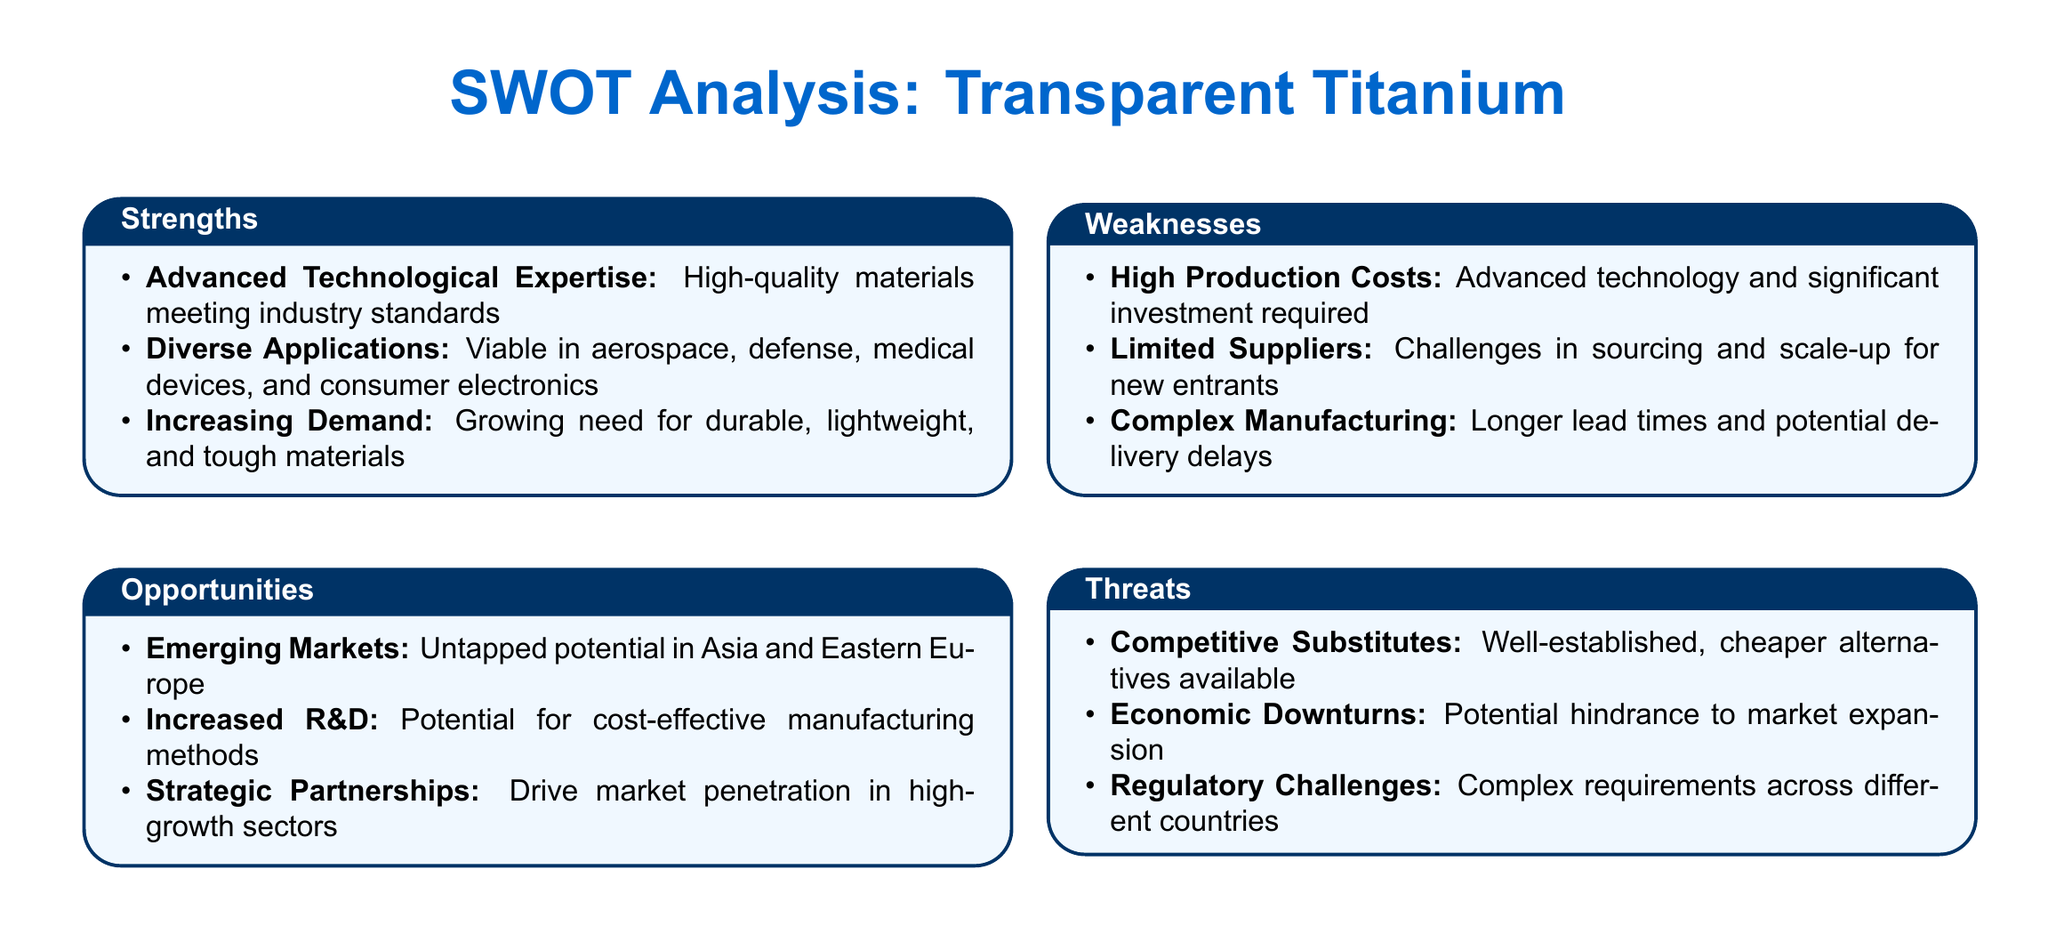What are the strengths listed for transparent titanium? The strengths are advanced technological expertise, diverse applications, and increasing demand as described in the document.
Answer: Advanced Technological Expertise, Diverse Applications, Increasing Demand What is one weakness of transparent titanium suppliers? The document lists high production costs as one of the weaknesses of transparent titanium suppliers.
Answer: High Production Costs What opportunities exist for transparent titanium? The opportunities highlight emerging markets, increased research and development, and strategic partnerships as future prospects in the analysis.
Answer: Emerging Markets, Increased R&D, Strategic Partnerships What threat is posed by competitors in the market? The document mentions competitive substitutes as a significant threat to transparent titanium suppliers.
Answer: Competitive Substitutes What is a potential hindrance to market expansion? According to the document, economic downturns could hinder market expansion for transparent titanium.
Answer: Economic Downturns What industries are mentioned as applications for transparent titanium? The document identifies aerospace, defense, medical devices, and consumer electronics as industries where transparent titanium can be applied.
Answer: Aerospace, Defense, Medical Devices, Consumer Electronics What challenges do new entrants face when sourcing materials? The document states that limited suppliers present challenges for scaling up for new entrants in the market.
Answer: Limited Suppliers How does the complexity of manufacturing affect lead times? The document indicates that complex manufacturing processes can lead to longer lead times and potential delays.
Answer: Longer lead times What is a possible benefit of increased research and development? The document suggests that increased research and development may lead to cost-effective manufacturing methods for transparent titanium.
Answer: Cost-effective manufacturing methods 